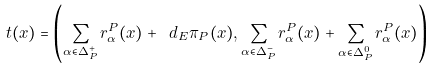Convert formula to latex. <formula><loc_0><loc_0><loc_500><loc_500>t ( x ) = \left ( \sum _ { \alpha \in \Delta ^ { + } _ { P } } r _ { \alpha } ^ { P } ( x ) + \ d _ { E } \pi _ { P } ( x ) , \sum _ { \alpha \in \Delta ^ { - } _ { P } } r _ { \alpha } ^ { P } ( x ) + \sum _ { \alpha \in \Delta ^ { 0 } _ { P } } r _ { \alpha } ^ { P } ( x ) \right )</formula> 